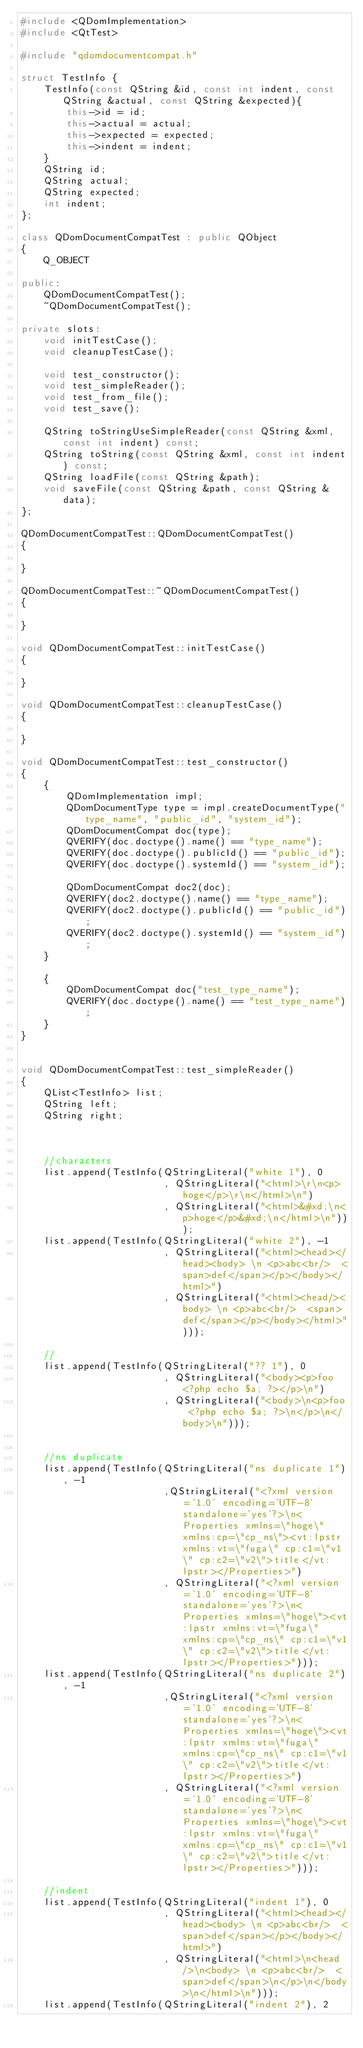<code> <loc_0><loc_0><loc_500><loc_500><_C++_>#include <QDomImplementation>
#include <QtTest>

#include "qdomdocumentcompat.h"

struct TestInfo {
    TestInfo(const QString &id, const int indent, const QString &actual, const QString &expected){
        this->id = id;
        this->actual = actual;
        this->expected = expected;
        this->indent = indent;
    }
    QString id;
    QString actual;
    QString expected;
    int indent;
};

class QDomDocumentCompatTest : public QObject
{
    Q_OBJECT

public:
    QDomDocumentCompatTest();
    ~QDomDocumentCompatTest();

private slots:
    void initTestCase();
    void cleanupTestCase();

    void test_constructor();
    void test_simpleReader();
    void test_from_file();
    void test_save();

    QString toStringUseSimpleReader(const QString &xml, const int indent) const;
    QString toString(const QString &xml, const int indent) const;
    QString loadFile(const QString &path);
    void saveFile(const QString &path, const QString &data);
};

QDomDocumentCompatTest::QDomDocumentCompatTest()
{

}

QDomDocumentCompatTest::~QDomDocumentCompatTest()
{

}

void QDomDocumentCompatTest::initTestCase()
{

}

void QDomDocumentCompatTest::cleanupTestCase()
{

}

void QDomDocumentCompatTest::test_constructor()
{
    {
        QDomImplementation impl;
        QDomDocumentType type = impl.createDocumentType("type_name", "public_id", "system_id");
        QDomDocumentCompat doc(type);
        QVERIFY(doc.doctype().name() == "type_name");
        QVERIFY(doc.doctype().publicId() == "public_id");
        QVERIFY(doc.doctype().systemId() == "system_id");

        QDomDocumentCompat doc2(doc);
        QVERIFY(doc2.doctype().name() == "type_name");
        QVERIFY(doc2.doctype().publicId() == "public_id");
        QVERIFY(doc2.doctype().systemId() == "system_id");
    }

    {
        QDomDocumentCompat doc("test_type_name");
        QVERIFY(doc.doctype().name() == "test_type_name");
    }
}


void QDomDocumentCompatTest::test_simpleReader()
{
    QList<TestInfo> list;
    QString left;
    QString right;



    //characters
    list.append(TestInfo(QStringLiteral("white 1"), 0
                         , QStringLiteral("<html>\r\n<p>hoge</p>\r\n</html>\n")
                         , QStringLiteral("<html>&#xd;\n<p>hoge</p>&#xd;\n</html>\n")));
    list.append(TestInfo(QStringLiteral("white 2"), -1
                         , QStringLiteral("<html><head></head><body> \n <p>abc<br/>  <span>def</span></p></body></html>")
                         , QStringLiteral("<html><head/><body> \n <p>abc<br/>  <span>def</span></p></body></html>")));

    //
    list.append(TestInfo(QStringLiteral("?? 1"), 0
                         , QStringLiteral("<body><p>foo <?php echo $a; ?></p>\n")
                         , QStringLiteral("<body>\n<p>foo <?php echo $a; ?>\n</p>\n</body>\n")));


    //ns duplicate
    list.append(TestInfo(QStringLiteral("ns duplicate 1"), -1
                         ,QStringLiteral("<?xml version='1.0' encoding='UTF-8' standalone='yes'?>\n<Properties xmlns=\"hoge\" xmlns:cp=\"cp_ns\"><vt:lpstr xmlns:vt=\"fuga\" cp:c1=\"v1\" cp:c2=\"v2\">title</vt:lpstr></Properties>")
                         , QStringLiteral("<?xml version='1.0' encoding='UTF-8' standalone='yes'?>\n<Properties xmlns=\"hoge\"><vt:lpstr xmlns:vt=\"fuga\" xmlns:cp=\"cp_ns\" cp:c1=\"v1\" cp:c2=\"v2\">title</vt:lpstr></Properties>")));
    list.append(TestInfo(QStringLiteral("ns duplicate 2"), -1
                         ,QStringLiteral("<?xml version='1.0' encoding='UTF-8' standalone='yes'?>\n<Properties xmlns=\"hoge\"><vt:lpstr xmlns:vt=\"fuga\" xmlns:cp=\"cp_ns\" cp:c1=\"v1\" cp:c2=\"v2\">title</vt:lpstr></Properties>")
                         , QStringLiteral("<?xml version='1.0' encoding='UTF-8' standalone='yes'?>\n<Properties xmlns=\"hoge\"><vt:lpstr xmlns:vt=\"fuga\" xmlns:cp=\"cp_ns\" cp:c1=\"v1\" cp:c2=\"v2\">title</vt:lpstr></Properties>")));

    //indent
    list.append(TestInfo(QStringLiteral("indent 1"), 0
                         , QStringLiteral("<html><head></head><body> \n <p>abc<br/>  <span>def</span></p></body></html>")
                         , QStringLiteral("<html>\n<head/>\n<body> \n <p>abc<br/>  <span>def</span>\n</p>\n</body>\n</html>\n")));
    list.append(TestInfo(QStringLiteral("indent 2"), 2</code> 